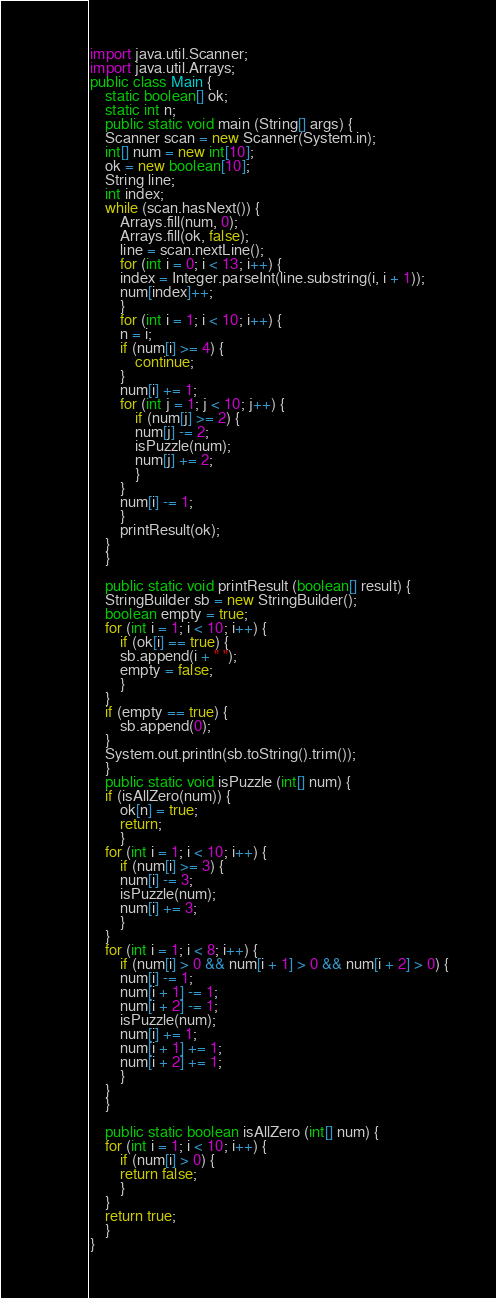Convert code to text. <code><loc_0><loc_0><loc_500><loc_500><_Java_>import java.util.Scanner;
import java.util.Arrays;
public class Main {
    static boolean[] ok;
    static int n;
    public static void main (String[] args) {
	Scanner scan = new Scanner(System.in);
	int[] num = new int[10];
	ok = new boolean[10];
	String line;
	int index;
	while (scan.hasNext()) {
	    Arrays.fill(num, 0);
	    Arrays.fill(ok, false);
	    line = scan.nextLine();
	    for (int i = 0; i < 13; i++) {
		index = Integer.parseInt(line.substring(i, i + 1));
		num[index]++;
	    }
	    for (int i = 1; i < 10; i++) {
		n = i;
		if (num[i] >= 4) {
		    continue;
		}
		num[i] += 1;
		for (int j = 1; j < 10; j++) {
		    if (num[j] >= 2) {
			num[j] -= 2;
			isPuzzle(num);
			num[j] += 2;
		    }
		}
		num[i] -= 1;
	    }
	    printResult(ok);
	}
    }

    public static void printResult (boolean[] result) {
	StringBuilder sb = new StringBuilder();
	boolean empty = true;
	for (int i = 1; i < 10; i++) {
	    if (ok[i] == true) {
		sb.append(i + " ");
		empty = false;
	    }
	}
	if (empty == true) {
	    sb.append(0);
	}
	System.out.println(sb.toString().trim());
    }
    public static void isPuzzle (int[] num) {
	if (isAllZero(num)) {
	    ok[n] = true;
	    return;
        }
	for (int i = 1; i < 10; i++) {
	    if (num[i] >= 3) {
		num[i] -= 3;
		isPuzzle(num);
		num[i] += 3;
	    }
	}
	for (int i = 1; i < 8; i++) {
	    if (num[i] > 0 && num[i + 1] > 0 && num[i + 2] > 0) {
		num[i] -= 1;
		num[i + 1] -= 1;
		num[i + 2] -= 1;
		isPuzzle(num);
		num[i] += 1;
		num[i + 1] += 1;
		num[i + 2] += 1;
	    }
	}
    }

    public static boolean isAllZero (int[] num) {
	for (int i = 1; i < 10; i++) {
	    if (num[i] > 0) {
		return false;
	    }
	}
	return true;
    }
}</code> 